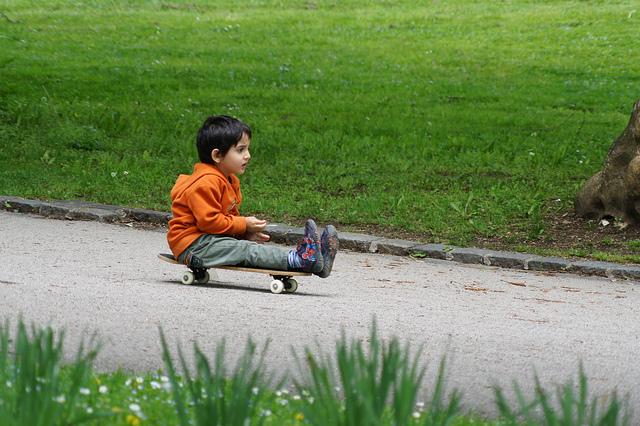Is this person wearing protective gear?
Write a very short answer. No. Is the child standing up on top of the skateboard?
Keep it brief. No. What is the motif etched or painted onto the window?
Short answer required. No window. How many people do you see?
Concise answer only. 1. What government document is needed to partake in this activity?
Short answer required. None. What color is the child's sweatshirt?
Keep it brief. Orange. Is there a curb?
Keep it brief. Yes. Who is traveling?
Keep it brief. Boy. What type of greenery has grown from the ground?
Keep it brief. Grass. 